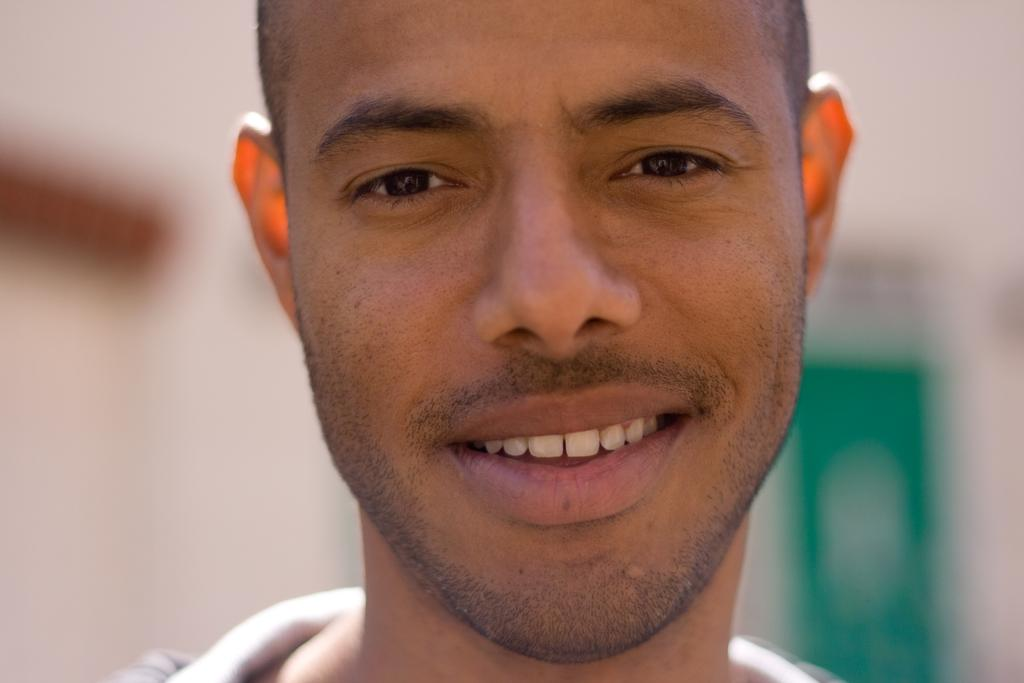What is the main subject of the image? There is a man's face in the image. What expression does the man have? The man is smiling. Can you describe the objects placed behind the man? The visibility of the objects placed behind the man is unclear, so it is difficult to describe them. What type of wheel is visible in the image? There is no wheel present in the image. Who is the man representing in the image? The image does not indicate that the man is representing anyone or anything. 